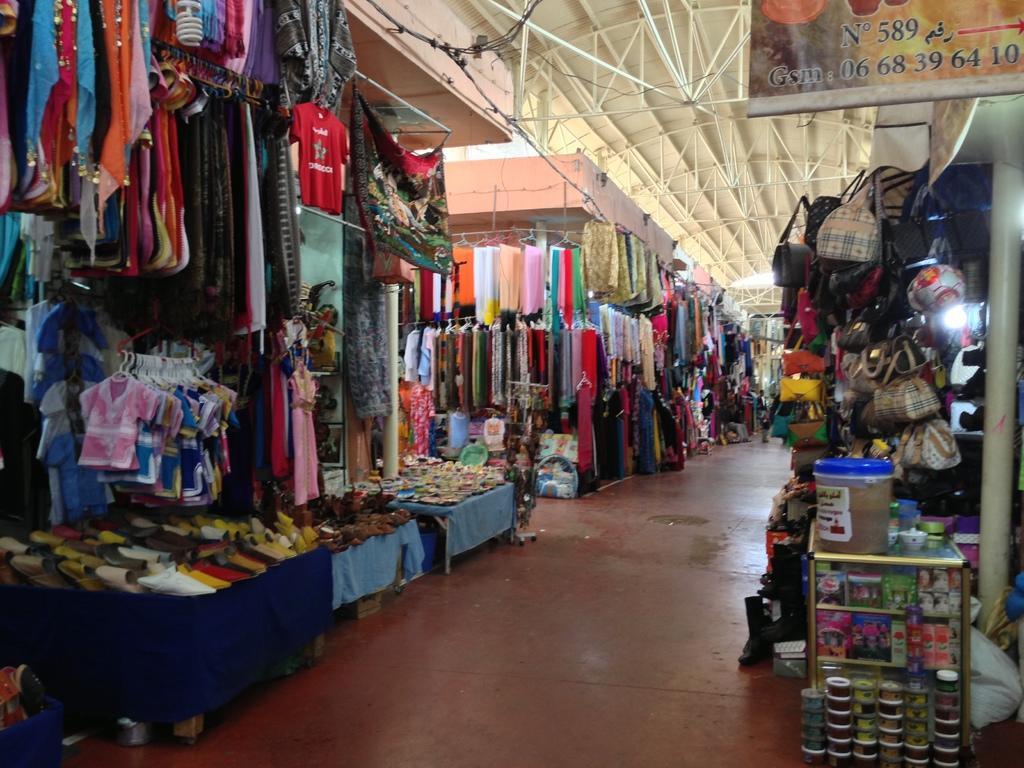Describe this image in one or two sentences. In this picture we can see stores, on the left side there are some hangers and clothes, at the left bottom we can see tables, there are some shoes present on these tables, on the right side we can see bags, at the right bottom we can see a plastic box and some other things, there is a board at the right top of the picture, we can see some metal rods at the top of the picture. 